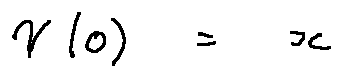Convert formula to latex. <formula><loc_0><loc_0><loc_500><loc_500>\gamma ( 0 ) = x</formula> 